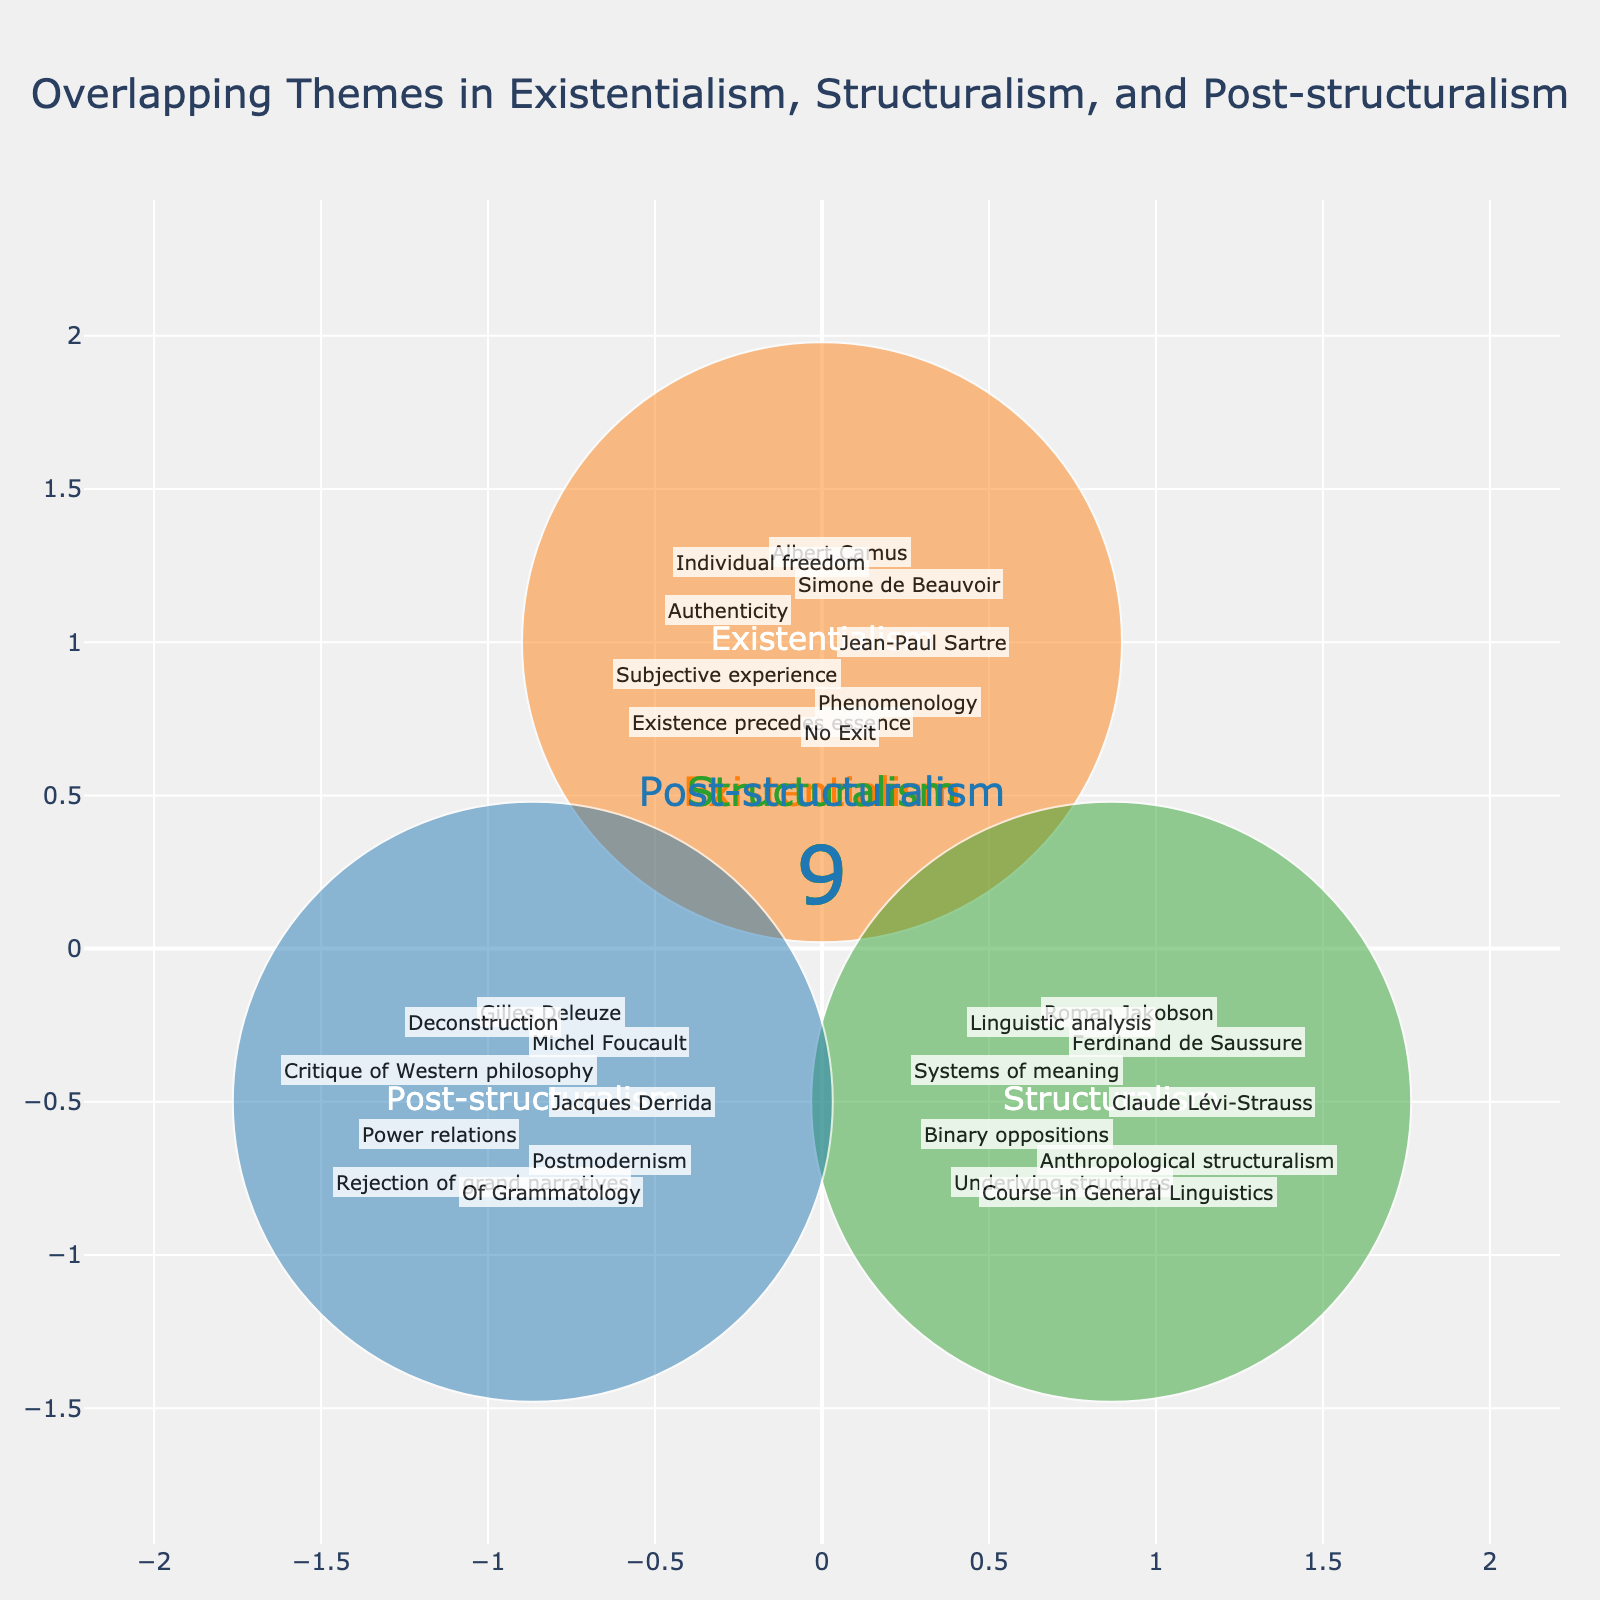What are the three primary intellectual movements depicted in the Venn diagram? The title of the plot is "Overlapping Themes in Existentialism, Structuralism, and Post-structuralism," indicating the three primary intellectual movements shown in the diagram.
Answer: Existentialism, Structuralism, Post-structuralism Which intellectual movement is associated with the philosopher Jean-Paul Sartre? Observing the elements annotated near "Existentialism" reveals Jean-Paul Sartre as one of the associated figures.
Answer: Existentialism How many unique elements are depicted for each intellectual movement? Each movement has a numerical indicator: Existentialism (9 elements), Structuralism (9 elements), Post-structuralism (9 elements), as shown by the indicators.
Answer: 9, 9, 9 Which intellectual movement uniquely includes the concept of "Deconstruction"? The concept "Deconstruction" is annotated near "Post-structuralism," indicating its unique association.
Answer: Post-structuralism What is the overlapping theme between Existentialism and Structuralism? By observing the annotations without overlapping areas, we can infer that "Binary oppositions" and other themes are unique to their respective categories, and there is no specific overlap between Existentialism and Structuralism indicated in the annotations.
Answer: No direct overlap Identify one shared or common element between Structuralism and Post-structuralism. By analyzing the annotations near Structuralism and Post-structuralism, "Systems of meaning" could be seen as a conceptual linkage, although not explicitly stated. Typically, looking for overlaps outside specific annotations might require inferring the themes conceptually.
Answer: Systems of meaning Which author is associated with the text "Of Grammatology"? The text "Of Grammatology" is annotated near "Post-structuralism".
Answer: Jacques Derrida What theme overlaps across all three intellectual movements? Since the diagram visually represents individual elements per category, directly overlapping themes per Venn logic would appear centrally, yet no specific shared conceptual theme is annotated exactly overlapping within all three categories.
Answer: No exclusive overlap Which movement includes both "Linguistic analysis" and "Anthropological structuralism"? Both "Linguistic analysis" and "Anthropological structuralism" are annotated near "Structuralism". Thus, both elements are included in this movement.
Answer: Structuralism What key work is associated with Claude Lévi-Strauss? The annotation near "Structuralism" includes Claude Lévi-Strauss, and one key work associated is not separately tagged but inferred contextually.
Answer: "Anthropological structuralism" 